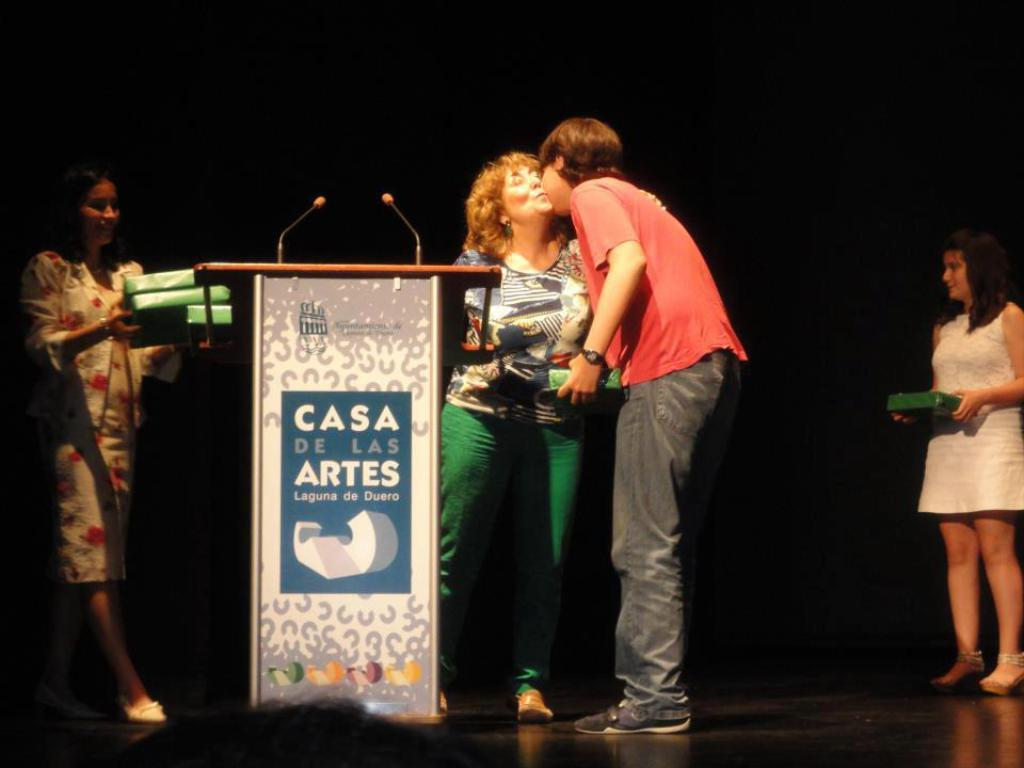What is the main subject of the image? The main subject of the image is a group of people. What are some of the people in the group holding? Some people in the group are holding boxes. What equipment is set up in front of the group? There are microphones and a podium in front of the group. How would you describe the background of the image? The background of the image is dark. Can you tell me how many cannons are placed on the edge of the quicksand in the image? There are no cannons or quicksand present in the image. 